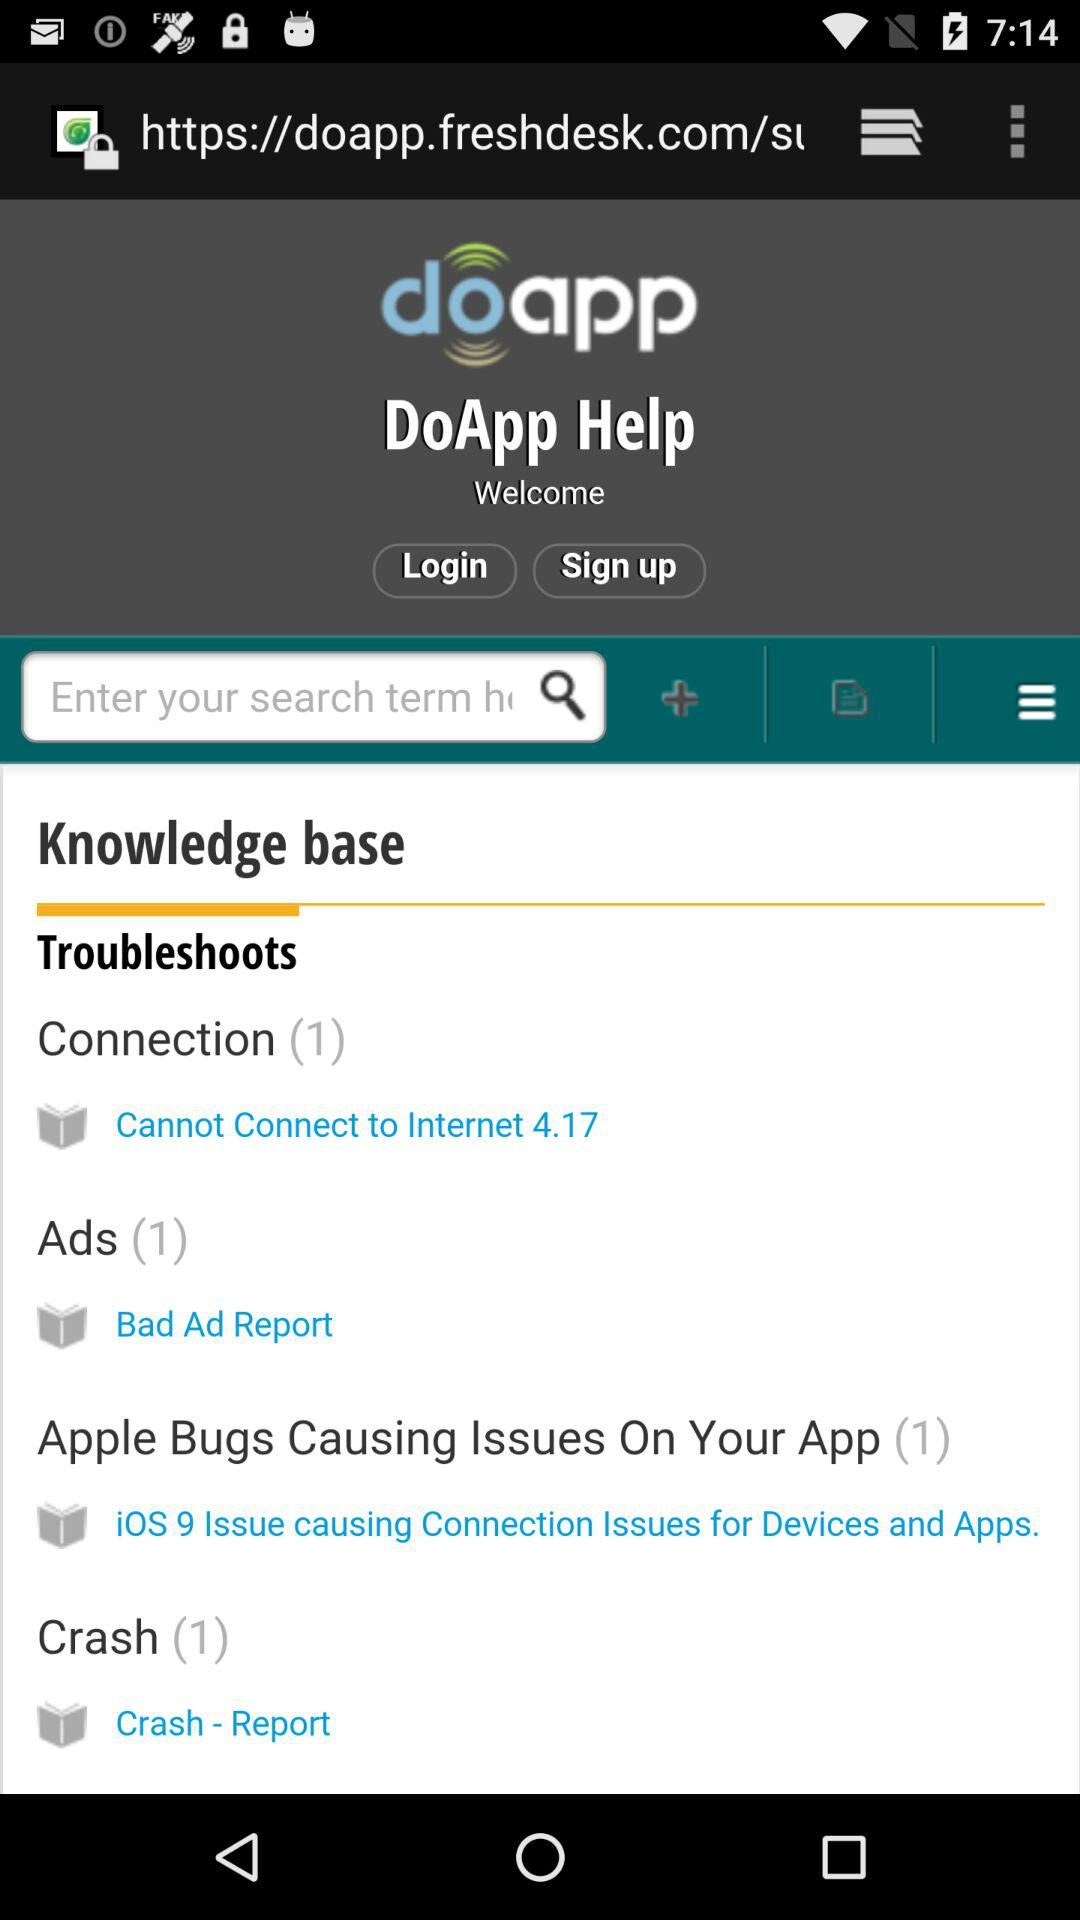How many more troubleshooting articles are there than crash articles?
Answer the question using a single word or phrase. 2 